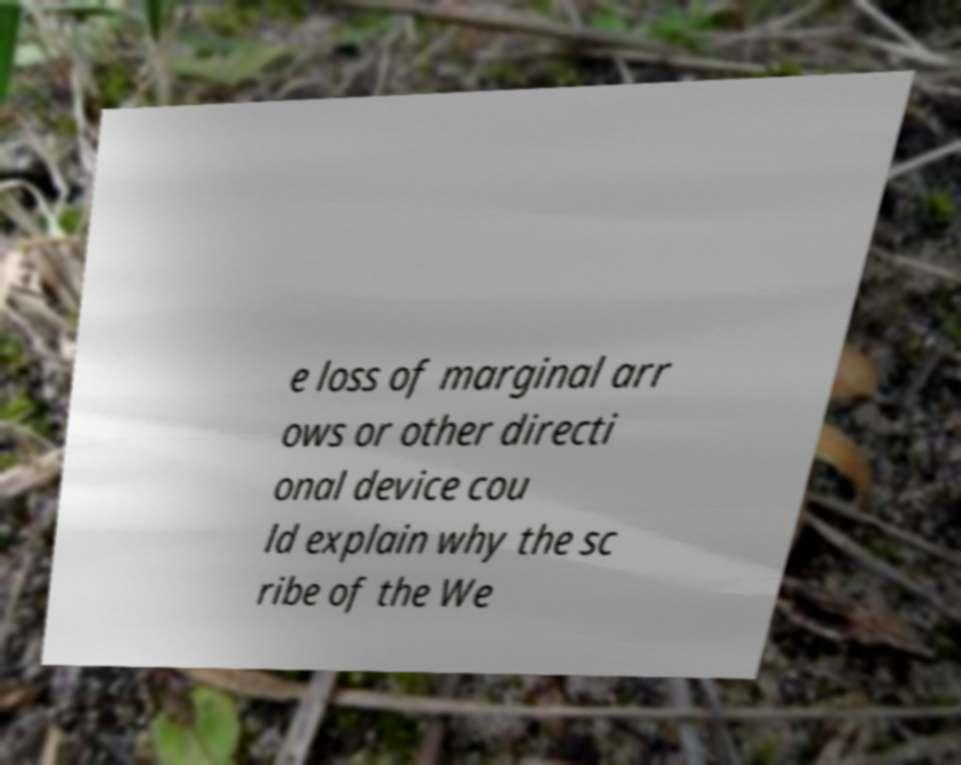Please read and relay the text visible in this image. What does it say? e loss of marginal arr ows or other directi onal device cou ld explain why the sc ribe of the We 